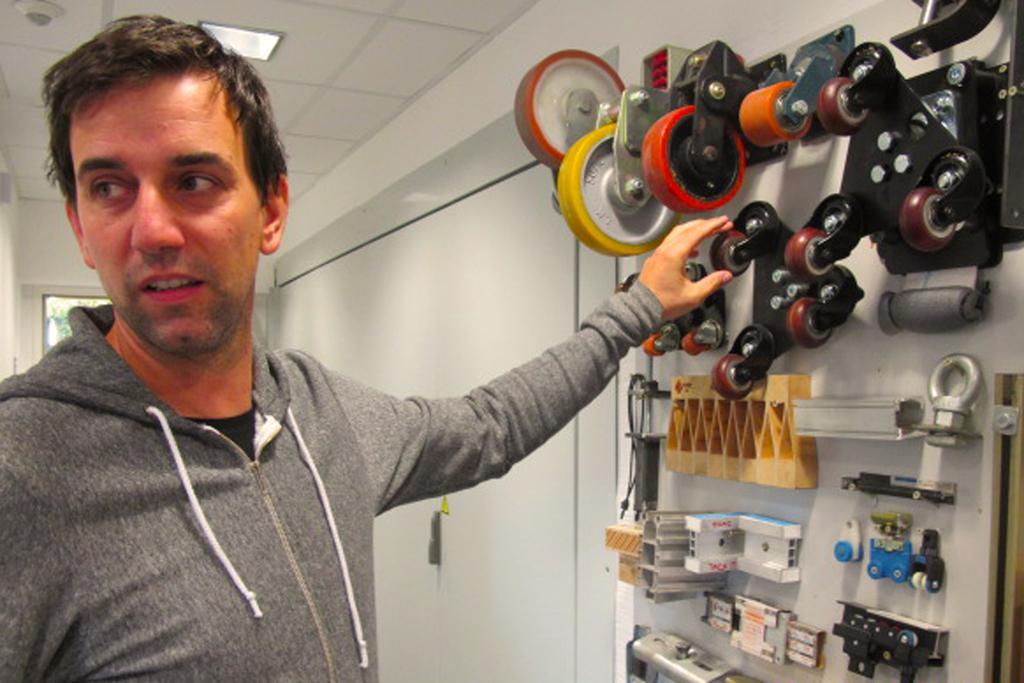In one or two sentences, can you explain what this image depicts? The man on the left side wearing a grey jacket is trying to touch the tools. On the right side, we see machine tools. Behind that, we see a white wall and beside that, we see a cupboard. Behind the man, we see a window. At the top of the picture, we see the ceiling of the room. 